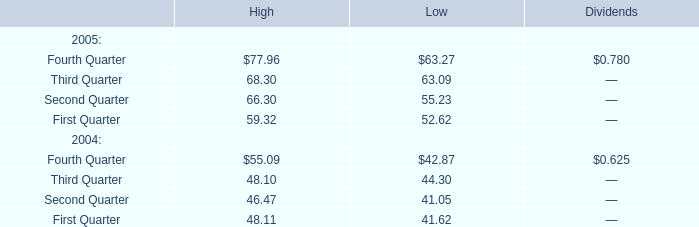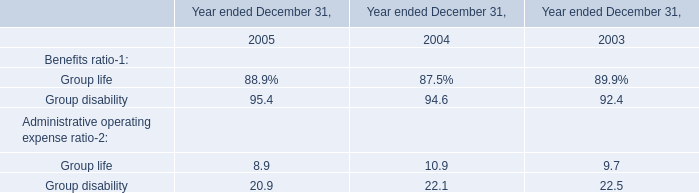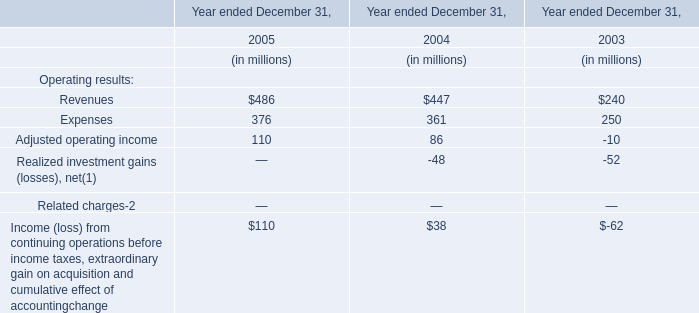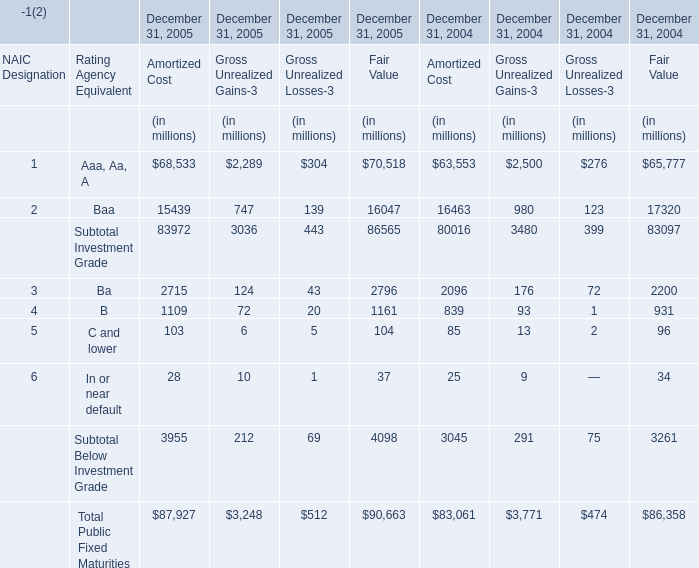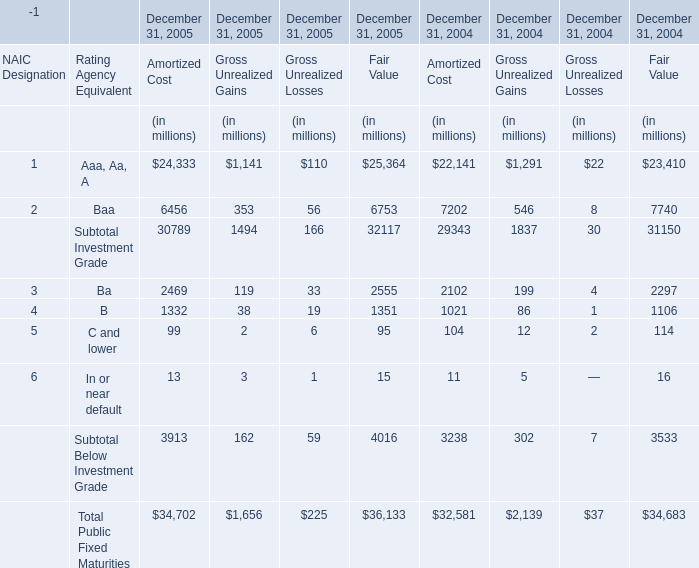What was the total amount of Amortized Cost in 2005 for December 31, 2005? (in million) 
Computations: ((((((68533 + 15439) + 2715) + 1109) + 103) + 28) + 87927)
Answer: 175854.0. 